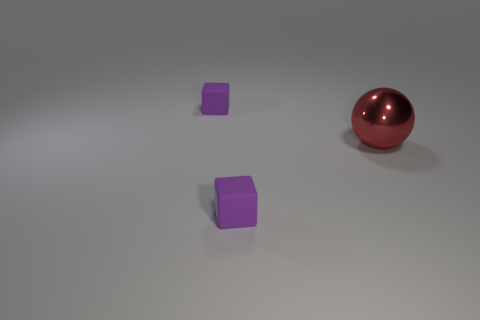Add 1 tiny matte blocks. How many objects exist? 4 Subtract all cubes. How many objects are left? 1 Add 2 large things. How many large things are left? 3 Add 1 red metal balls. How many red metal balls exist? 2 Subtract 0 green cubes. How many objects are left? 3 Subtract 1 balls. How many balls are left? 0 Subtract all brown cubes. Subtract all purple cylinders. How many cubes are left? 2 Subtract all purple things. Subtract all metal balls. How many objects are left? 0 